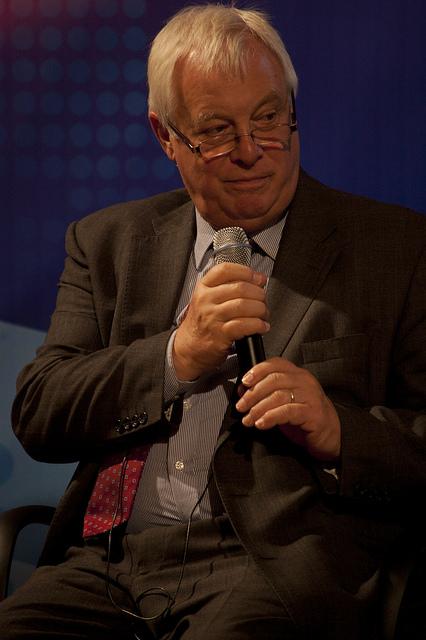Is he wearing a tie?
Short answer required. No. What is the man holding?
Short answer required. Microphone. What is he holding?
Write a very short answer. Microphone. Is the man wearing glasses?
Keep it brief. Yes. How many hands are in the photo?
Give a very brief answer. 2. Is this man married?
Be succinct. Yes. Is the man young or old?
Answer briefly. Old. 